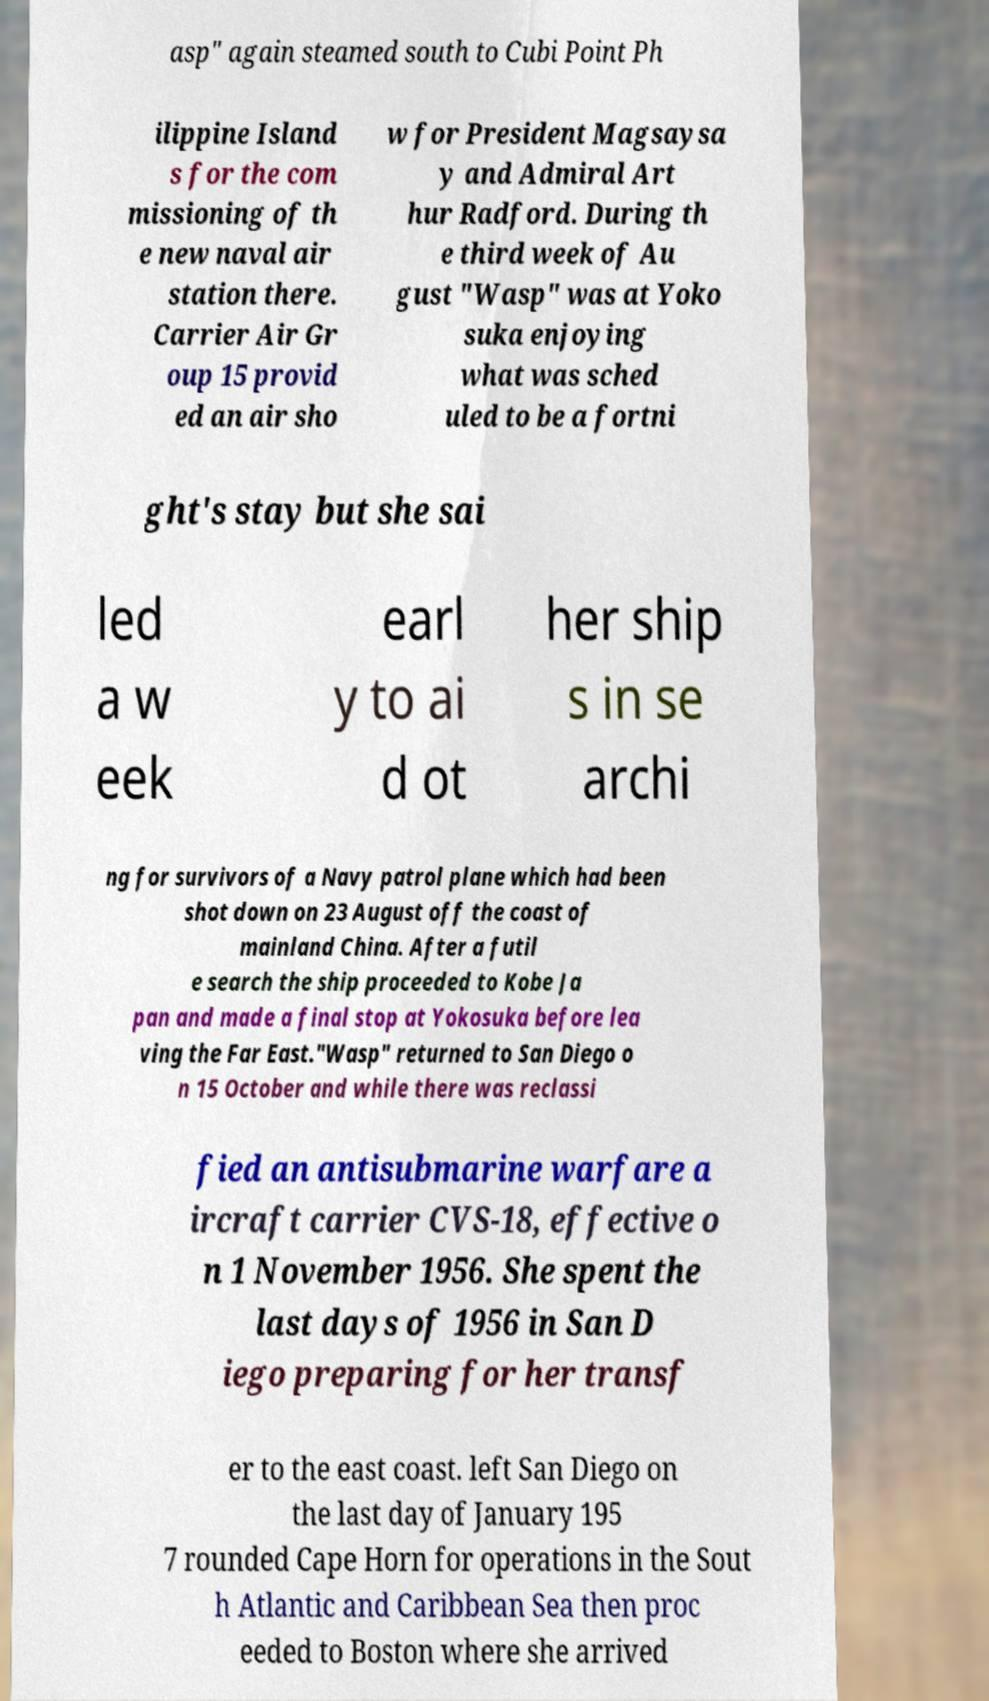Can you accurately transcribe the text from the provided image for me? asp" again steamed south to Cubi Point Ph ilippine Island s for the com missioning of th e new naval air station there. Carrier Air Gr oup 15 provid ed an air sho w for President Magsaysa y and Admiral Art hur Radford. During th e third week of Au gust "Wasp" was at Yoko suka enjoying what was sched uled to be a fortni ght's stay but she sai led a w eek earl y to ai d ot her ship s in se archi ng for survivors of a Navy patrol plane which had been shot down on 23 August off the coast of mainland China. After a futil e search the ship proceeded to Kobe Ja pan and made a final stop at Yokosuka before lea ving the Far East."Wasp" returned to San Diego o n 15 October and while there was reclassi fied an antisubmarine warfare a ircraft carrier CVS-18, effective o n 1 November 1956. She spent the last days of 1956 in San D iego preparing for her transf er to the east coast. left San Diego on the last day of January 195 7 rounded Cape Horn for operations in the Sout h Atlantic and Caribbean Sea then proc eeded to Boston where she arrived 